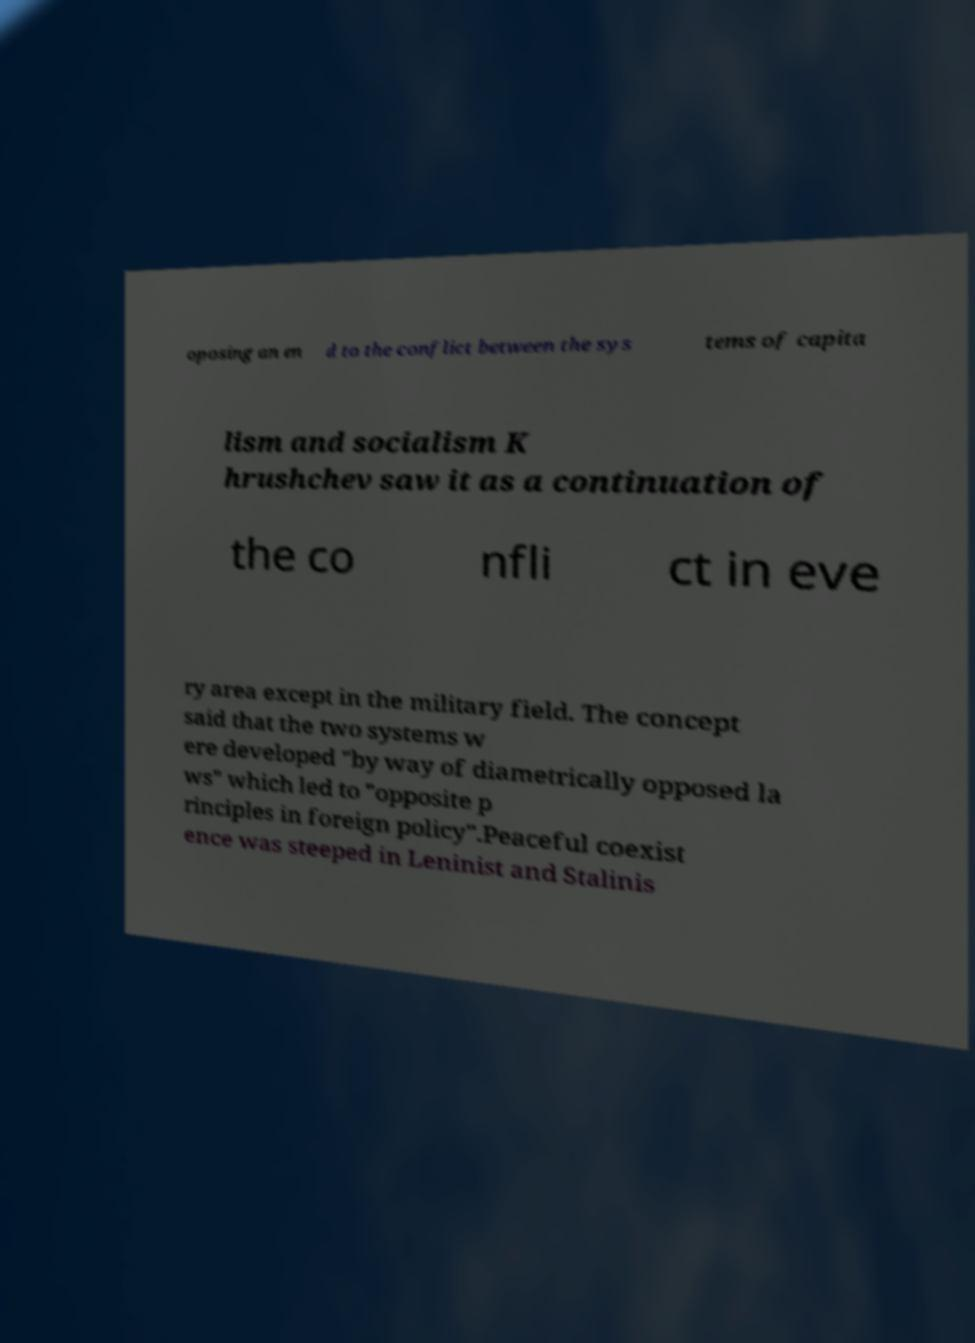Please read and relay the text visible in this image. What does it say? oposing an en d to the conflict between the sys tems of capita lism and socialism K hrushchev saw it as a continuation of the co nfli ct in eve ry area except in the military field. The concept said that the two systems w ere developed "by way of diametrically opposed la ws" which led to "opposite p rinciples in foreign policy".Peaceful coexist ence was steeped in Leninist and Stalinis 